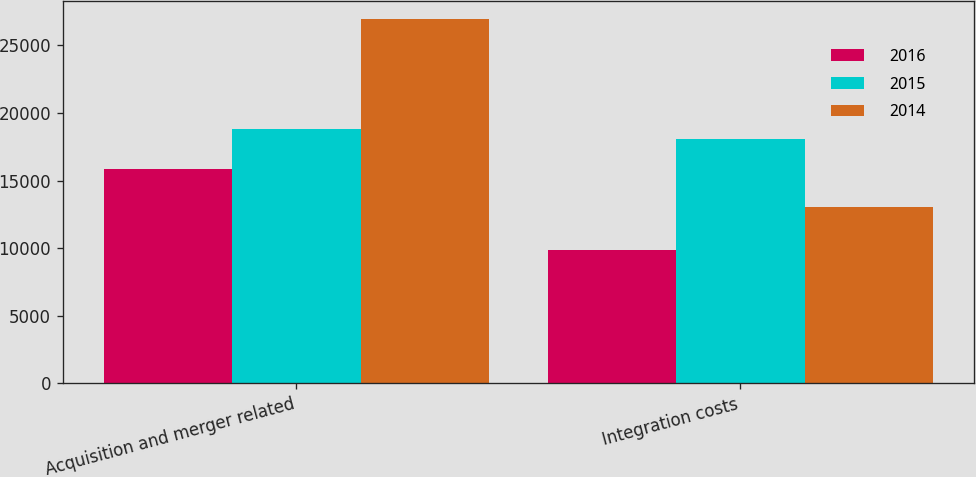<chart> <loc_0><loc_0><loc_500><loc_500><stacked_bar_chart><ecel><fcel>Acquisition and merger related<fcel>Integration costs<nl><fcel>2016<fcel>15875<fcel>9901<nl><fcel>2015<fcel>18799<fcel>18097<nl><fcel>2014<fcel>26969<fcel>13057<nl></chart> 